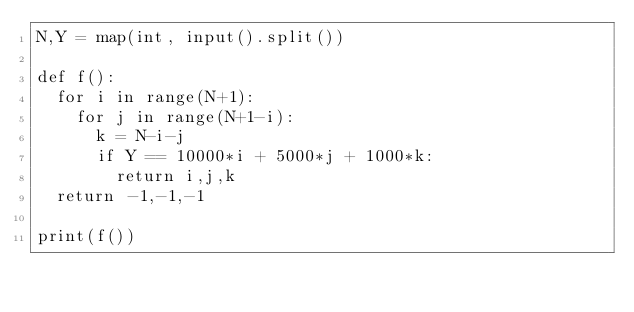Convert code to text. <code><loc_0><loc_0><loc_500><loc_500><_Python_>N,Y = map(int, input().split())

def f():
  for i in range(N+1):
    for j in range(N+1-i):
      k = N-i-j
      if Y == 10000*i + 5000*j + 1000*k:
        return i,j,k
  return -1,-1,-1

print(f())</code> 